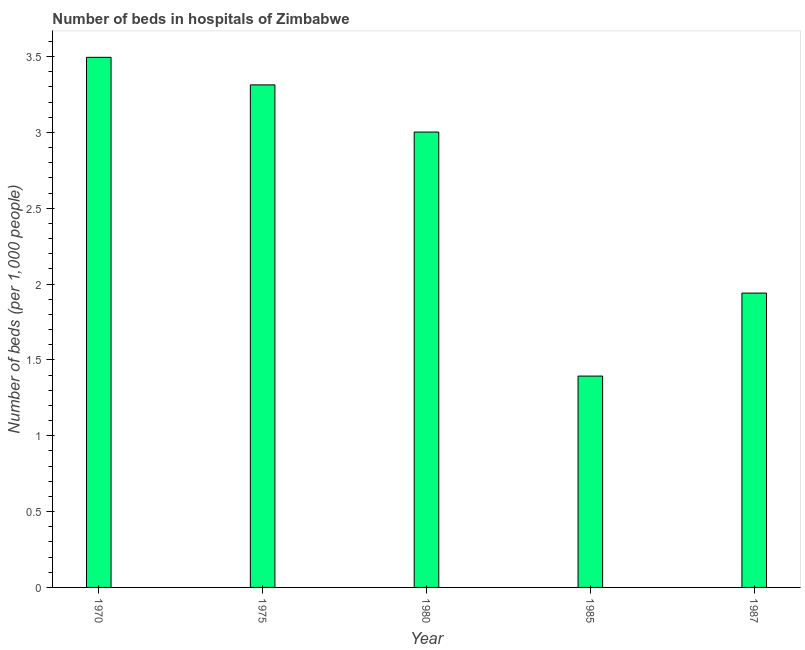Does the graph contain any zero values?
Ensure brevity in your answer.  No. Does the graph contain grids?
Ensure brevity in your answer.  No. What is the title of the graph?
Your answer should be very brief. Number of beds in hospitals of Zimbabwe. What is the label or title of the X-axis?
Offer a terse response. Year. What is the label or title of the Y-axis?
Make the answer very short. Number of beds (per 1,0 people). What is the number of hospital beds in 1985?
Give a very brief answer. 1.39. Across all years, what is the maximum number of hospital beds?
Keep it short and to the point. 3.5. Across all years, what is the minimum number of hospital beds?
Provide a succinct answer. 1.39. What is the sum of the number of hospital beds?
Provide a short and direct response. 13.15. What is the difference between the number of hospital beds in 1980 and 1985?
Ensure brevity in your answer.  1.61. What is the average number of hospital beds per year?
Offer a very short reply. 2.63. What is the median number of hospital beds?
Make the answer very short. 3. Do a majority of the years between 1987 and 1975 (inclusive) have number of hospital beds greater than 1.2 %?
Provide a short and direct response. Yes. What is the ratio of the number of hospital beds in 1970 to that in 1980?
Provide a short and direct response. 1.16. Is the number of hospital beds in 1970 less than that in 1987?
Your answer should be very brief. No. Is the difference between the number of hospital beds in 1980 and 1985 greater than the difference between any two years?
Provide a succinct answer. No. What is the difference between the highest and the second highest number of hospital beds?
Your answer should be compact. 0.18. What is the difference between the highest and the lowest number of hospital beds?
Provide a short and direct response. 2.1. Are all the bars in the graph horizontal?
Keep it short and to the point. No. What is the difference between two consecutive major ticks on the Y-axis?
Your answer should be compact. 0.5. Are the values on the major ticks of Y-axis written in scientific E-notation?
Your answer should be very brief. No. What is the Number of beds (per 1,000 people) of 1970?
Keep it short and to the point. 3.5. What is the Number of beds (per 1,000 people) of 1975?
Give a very brief answer. 3.31. What is the Number of beds (per 1,000 people) in 1980?
Make the answer very short. 3. What is the Number of beds (per 1,000 people) in 1985?
Give a very brief answer. 1.39. What is the Number of beds (per 1,000 people) of 1987?
Your response must be concise. 1.94. What is the difference between the Number of beds (per 1,000 people) in 1970 and 1975?
Give a very brief answer. 0.18. What is the difference between the Number of beds (per 1,000 people) in 1970 and 1980?
Provide a short and direct response. 0.49. What is the difference between the Number of beds (per 1,000 people) in 1970 and 1985?
Keep it short and to the point. 2.1. What is the difference between the Number of beds (per 1,000 people) in 1970 and 1987?
Ensure brevity in your answer.  1.55. What is the difference between the Number of beds (per 1,000 people) in 1975 and 1980?
Offer a very short reply. 0.31. What is the difference between the Number of beds (per 1,000 people) in 1975 and 1985?
Keep it short and to the point. 1.92. What is the difference between the Number of beds (per 1,000 people) in 1975 and 1987?
Your response must be concise. 1.37. What is the difference between the Number of beds (per 1,000 people) in 1980 and 1985?
Offer a terse response. 1.61. What is the difference between the Number of beds (per 1,000 people) in 1980 and 1987?
Offer a terse response. 1.06. What is the difference between the Number of beds (per 1,000 people) in 1985 and 1987?
Make the answer very short. -0.55. What is the ratio of the Number of beds (per 1,000 people) in 1970 to that in 1975?
Make the answer very short. 1.05. What is the ratio of the Number of beds (per 1,000 people) in 1970 to that in 1980?
Make the answer very short. 1.16. What is the ratio of the Number of beds (per 1,000 people) in 1970 to that in 1985?
Offer a very short reply. 2.51. What is the ratio of the Number of beds (per 1,000 people) in 1970 to that in 1987?
Offer a very short reply. 1.8. What is the ratio of the Number of beds (per 1,000 people) in 1975 to that in 1980?
Offer a terse response. 1.1. What is the ratio of the Number of beds (per 1,000 people) in 1975 to that in 1985?
Your answer should be compact. 2.38. What is the ratio of the Number of beds (per 1,000 people) in 1975 to that in 1987?
Offer a terse response. 1.71. What is the ratio of the Number of beds (per 1,000 people) in 1980 to that in 1985?
Offer a terse response. 2.15. What is the ratio of the Number of beds (per 1,000 people) in 1980 to that in 1987?
Your answer should be compact. 1.55. What is the ratio of the Number of beds (per 1,000 people) in 1985 to that in 1987?
Your answer should be compact. 0.72. 